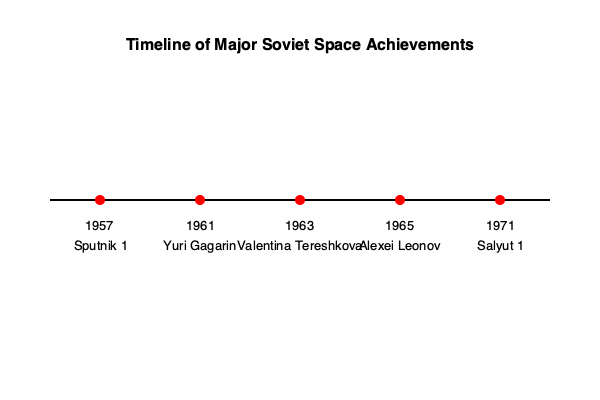Based on the timeline of Soviet space achievements shown above, which milestone represents the first human to conduct a spacewalk, and in what year did this historic event occur? To answer this question, we need to examine the timeline carefully:

1. 1957: Sputnik 1 - This was the first artificial satellite launched into orbit.
2. 1961: Yuri Gagarin - He was the first human to journey into outer space.
3. 1963: Valentina Tereshkova - She became the first woman in space.
4. 1965: Alexei Leonov - This is the milestone we're looking for.
5. 1971: Salyut 1 - This was the first space station.

Alexei Leonov's achievement in 1965 stands out as the milestone representing the first human to conduct a spacewalk. On March 18, 1965, Leonov exited the Voskhod 2 spacecraft for 12 minutes and 9 seconds, becoming the first person to walk in space.

This event was a significant accomplishment for the Soviet space program, demonstrating that humans could survive and operate outside of a spacecraft in the vacuum of space. It paved the way for future spacewalks and extravehicular activities that would become crucial for space station maintenance, satellite repairs, and other space operations.
Answer: Alexei Leonov, 1965 